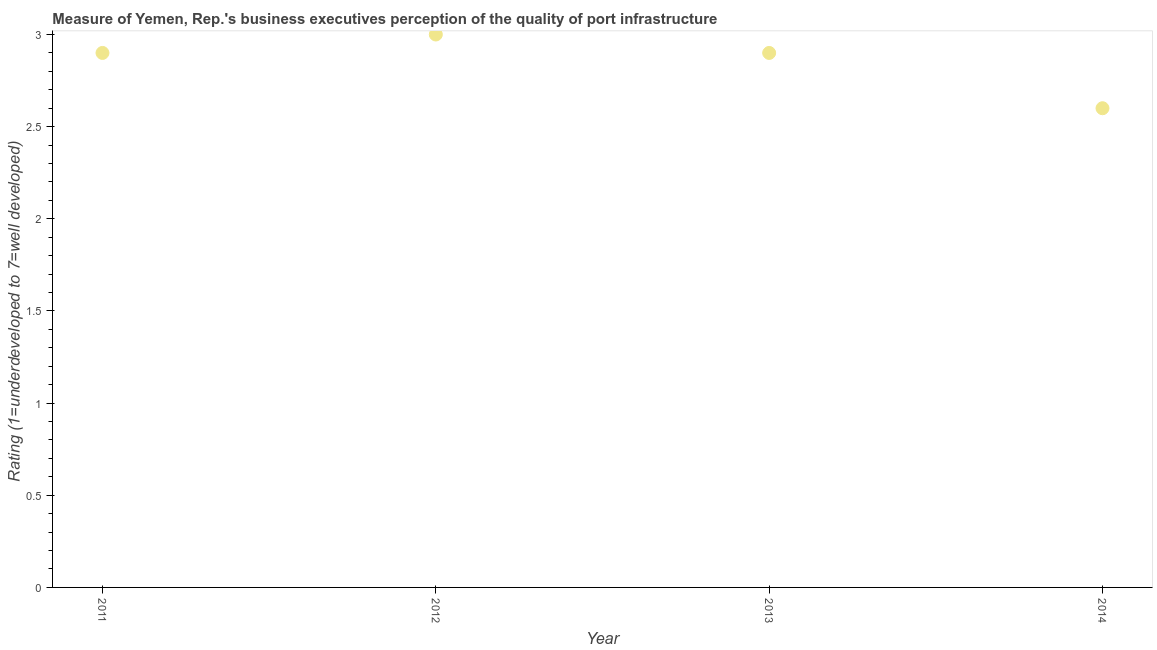What is the rating measuring quality of port infrastructure in 2012?
Make the answer very short. 3. Across all years, what is the minimum rating measuring quality of port infrastructure?
Your answer should be very brief. 2.6. In which year was the rating measuring quality of port infrastructure maximum?
Keep it short and to the point. 2012. What is the sum of the rating measuring quality of port infrastructure?
Give a very brief answer. 11.4. What is the average rating measuring quality of port infrastructure per year?
Your answer should be very brief. 2.85. What is the median rating measuring quality of port infrastructure?
Provide a succinct answer. 2.9. In how many years, is the rating measuring quality of port infrastructure greater than 2.5 ?
Keep it short and to the point. 4. Do a majority of the years between 2011 and 2012 (inclusive) have rating measuring quality of port infrastructure greater than 2.4 ?
Ensure brevity in your answer.  Yes. What is the ratio of the rating measuring quality of port infrastructure in 2012 to that in 2013?
Your answer should be very brief. 1.03. Is the rating measuring quality of port infrastructure in 2011 less than that in 2012?
Provide a succinct answer. Yes. What is the difference between the highest and the second highest rating measuring quality of port infrastructure?
Offer a terse response. 0.1. What is the difference between the highest and the lowest rating measuring quality of port infrastructure?
Offer a terse response. 0.4. In how many years, is the rating measuring quality of port infrastructure greater than the average rating measuring quality of port infrastructure taken over all years?
Provide a succinct answer. 3. How many dotlines are there?
Your answer should be very brief. 1. What is the difference between two consecutive major ticks on the Y-axis?
Your response must be concise. 0.5. Are the values on the major ticks of Y-axis written in scientific E-notation?
Offer a terse response. No. Does the graph contain any zero values?
Make the answer very short. No. Does the graph contain grids?
Give a very brief answer. No. What is the title of the graph?
Provide a short and direct response. Measure of Yemen, Rep.'s business executives perception of the quality of port infrastructure. What is the label or title of the Y-axis?
Provide a succinct answer. Rating (1=underdeveloped to 7=well developed) . What is the Rating (1=underdeveloped to 7=well developed)  in 2011?
Your response must be concise. 2.9. What is the Rating (1=underdeveloped to 7=well developed)  in 2012?
Offer a terse response. 3. What is the Rating (1=underdeveloped to 7=well developed)  in 2013?
Offer a terse response. 2.9. What is the Rating (1=underdeveloped to 7=well developed)  in 2014?
Offer a terse response. 2.6. What is the difference between the Rating (1=underdeveloped to 7=well developed)  in 2011 and 2012?
Offer a very short reply. -0.1. What is the difference between the Rating (1=underdeveloped to 7=well developed)  in 2011 and 2014?
Offer a terse response. 0.3. What is the difference between the Rating (1=underdeveloped to 7=well developed)  in 2012 and 2013?
Keep it short and to the point. 0.1. What is the difference between the Rating (1=underdeveloped to 7=well developed)  in 2012 and 2014?
Offer a terse response. 0.4. What is the ratio of the Rating (1=underdeveloped to 7=well developed)  in 2011 to that in 2012?
Offer a terse response. 0.97. What is the ratio of the Rating (1=underdeveloped to 7=well developed)  in 2011 to that in 2014?
Offer a very short reply. 1.11. What is the ratio of the Rating (1=underdeveloped to 7=well developed)  in 2012 to that in 2013?
Your answer should be very brief. 1.03. What is the ratio of the Rating (1=underdeveloped to 7=well developed)  in 2012 to that in 2014?
Give a very brief answer. 1.15. What is the ratio of the Rating (1=underdeveloped to 7=well developed)  in 2013 to that in 2014?
Provide a succinct answer. 1.11. 